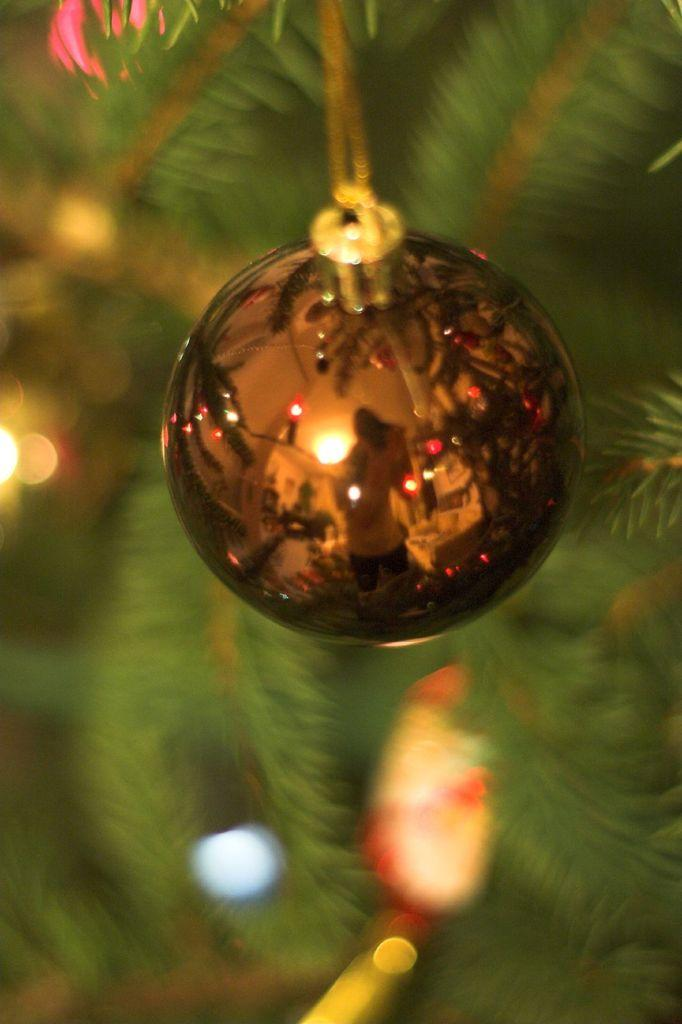What is the overall quality of the image? The image is blurry. What can be seen in the center of the image? There is an object hanging in the center of the image. What type of vegetation is visible in the background of the image? There are leaves visible in the background of the image. What is the weight of the cow in the image? There is no cow present in the image, so it is not possible to determine its weight. 